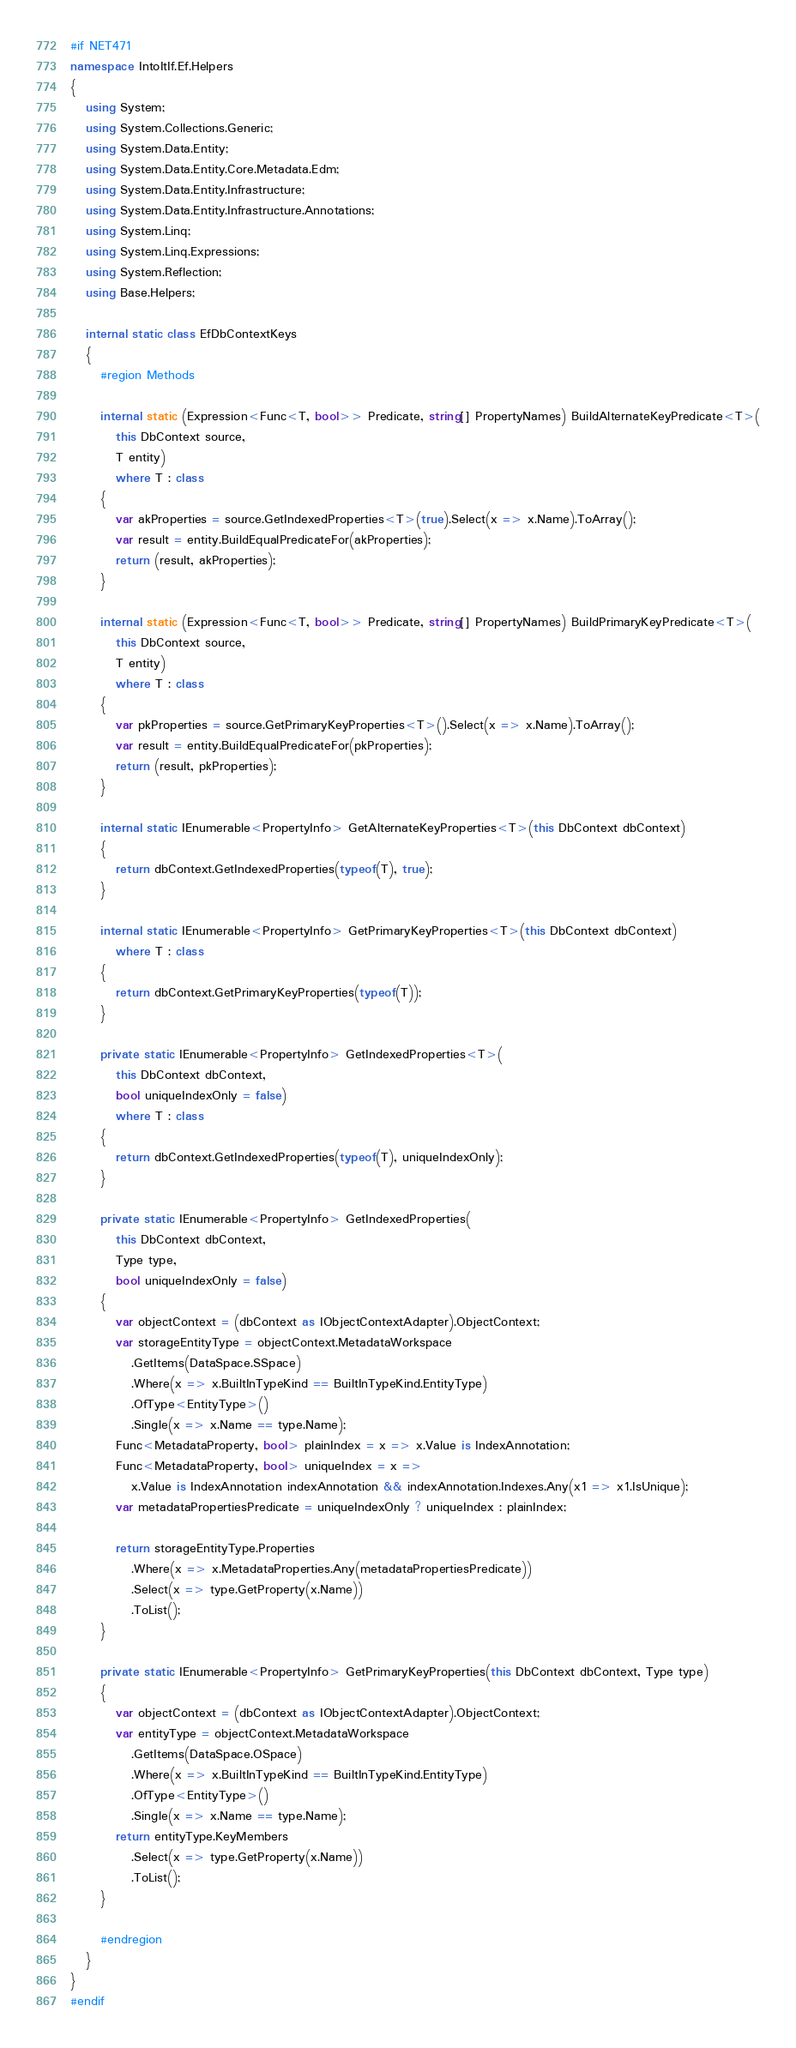<code> <loc_0><loc_0><loc_500><loc_500><_C#_>#if NET471
namespace IntoItIf.Ef.Helpers
{
   using System;
   using System.Collections.Generic;
   using System.Data.Entity;
   using System.Data.Entity.Core.Metadata.Edm;
   using System.Data.Entity.Infrastructure;
   using System.Data.Entity.Infrastructure.Annotations;
   using System.Linq;
   using System.Linq.Expressions;
   using System.Reflection;
   using Base.Helpers;

   internal static class EfDbContextKeys
   {
      #region Methods

      internal static (Expression<Func<T, bool>> Predicate, string[] PropertyNames) BuildAlternateKeyPredicate<T>(
         this DbContext source,
         T entity)
         where T : class
      {
         var akProperties = source.GetIndexedProperties<T>(true).Select(x => x.Name).ToArray();
         var result = entity.BuildEqualPredicateFor(akProperties);
         return (result, akProperties);
      }

      internal static (Expression<Func<T, bool>> Predicate, string[] PropertyNames) BuildPrimaryKeyPredicate<T>(
         this DbContext source,
         T entity)
         where T : class
      {
         var pkProperties = source.GetPrimaryKeyProperties<T>().Select(x => x.Name).ToArray();
         var result = entity.BuildEqualPredicateFor(pkProperties);
         return (result, pkProperties);
      }

      internal static IEnumerable<PropertyInfo> GetAlternateKeyProperties<T>(this DbContext dbContext)
      {
         return dbContext.GetIndexedProperties(typeof(T), true);
      }

      internal static IEnumerable<PropertyInfo> GetPrimaryKeyProperties<T>(this DbContext dbContext)
         where T : class
      {
         return dbContext.GetPrimaryKeyProperties(typeof(T));
      }

      private static IEnumerable<PropertyInfo> GetIndexedProperties<T>(
         this DbContext dbContext,
         bool uniqueIndexOnly = false)
         where T : class
      {
         return dbContext.GetIndexedProperties(typeof(T), uniqueIndexOnly);
      }

      private static IEnumerable<PropertyInfo> GetIndexedProperties(
         this DbContext dbContext,
         Type type,
         bool uniqueIndexOnly = false)
      {
         var objectContext = (dbContext as IObjectContextAdapter).ObjectContext;
         var storageEntityType = objectContext.MetadataWorkspace
            .GetItems(DataSpace.SSpace)
            .Where(x => x.BuiltInTypeKind == BuiltInTypeKind.EntityType)
            .OfType<EntityType>()
            .Single(x => x.Name == type.Name);
         Func<MetadataProperty, bool> plainIndex = x => x.Value is IndexAnnotation;
         Func<MetadataProperty, bool> uniqueIndex = x =>
            x.Value is IndexAnnotation indexAnnotation && indexAnnotation.Indexes.Any(x1 => x1.IsUnique);
         var metadataPropertiesPredicate = uniqueIndexOnly ? uniqueIndex : plainIndex;

         return storageEntityType.Properties
            .Where(x => x.MetadataProperties.Any(metadataPropertiesPredicate))
            .Select(x => type.GetProperty(x.Name))
            .ToList();
      }

      private static IEnumerable<PropertyInfo> GetPrimaryKeyProperties(this DbContext dbContext, Type type)
      {
         var objectContext = (dbContext as IObjectContextAdapter).ObjectContext;
         var entityType = objectContext.MetadataWorkspace
            .GetItems(DataSpace.OSpace)
            .Where(x => x.BuiltInTypeKind == BuiltInTypeKind.EntityType)
            .OfType<EntityType>()
            .Single(x => x.Name == type.Name);
         return entityType.KeyMembers
            .Select(x => type.GetProperty(x.Name))
            .ToList();
      }

      #endregion
   }
}
#endif</code> 